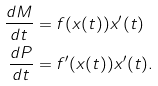<formula> <loc_0><loc_0><loc_500><loc_500>\frac { d M } { d t } & = f ( x ( t ) ) x ^ { \prime } ( t ) \\ \frac { d P } { d t } & = f ^ { \prime } ( x ( t ) ) x ^ { \prime } ( t ) .</formula> 